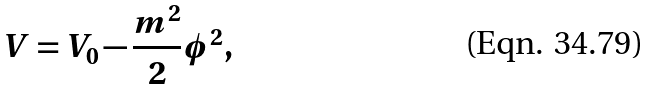<formula> <loc_0><loc_0><loc_500><loc_500>V = V _ { 0 } - \frac { m ^ { 2 } } { 2 } \phi ^ { 2 } ,</formula> 